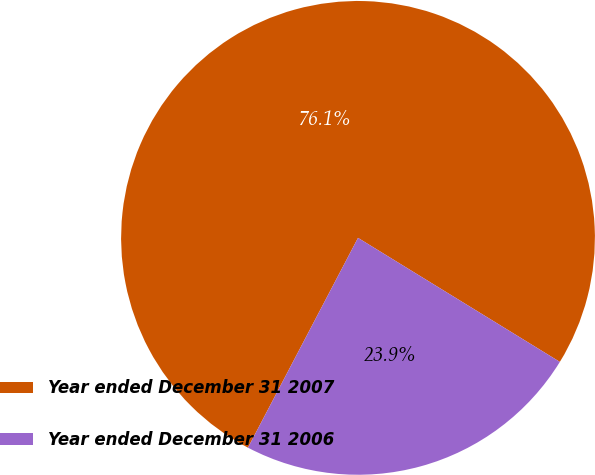Convert chart. <chart><loc_0><loc_0><loc_500><loc_500><pie_chart><fcel>Year ended December 31 2007<fcel>Year ended December 31 2006<nl><fcel>76.08%<fcel>23.92%<nl></chart> 